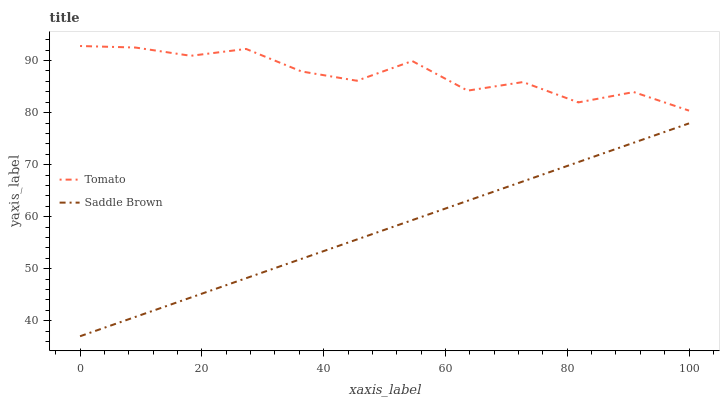Does Saddle Brown have the minimum area under the curve?
Answer yes or no. Yes. Does Tomato have the maximum area under the curve?
Answer yes or no. Yes. Does Saddle Brown have the maximum area under the curve?
Answer yes or no. No. Is Saddle Brown the smoothest?
Answer yes or no. Yes. Is Tomato the roughest?
Answer yes or no. Yes. Is Saddle Brown the roughest?
Answer yes or no. No. Does Saddle Brown have the lowest value?
Answer yes or no. Yes. Does Tomato have the highest value?
Answer yes or no. Yes. Does Saddle Brown have the highest value?
Answer yes or no. No. Is Saddle Brown less than Tomato?
Answer yes or no. Yes. Is Tomato greater than Saddle Brown?
Answer yes or no. Yes. Does Saddle Brown intersect Tomato?
Answer yes or no. No. 